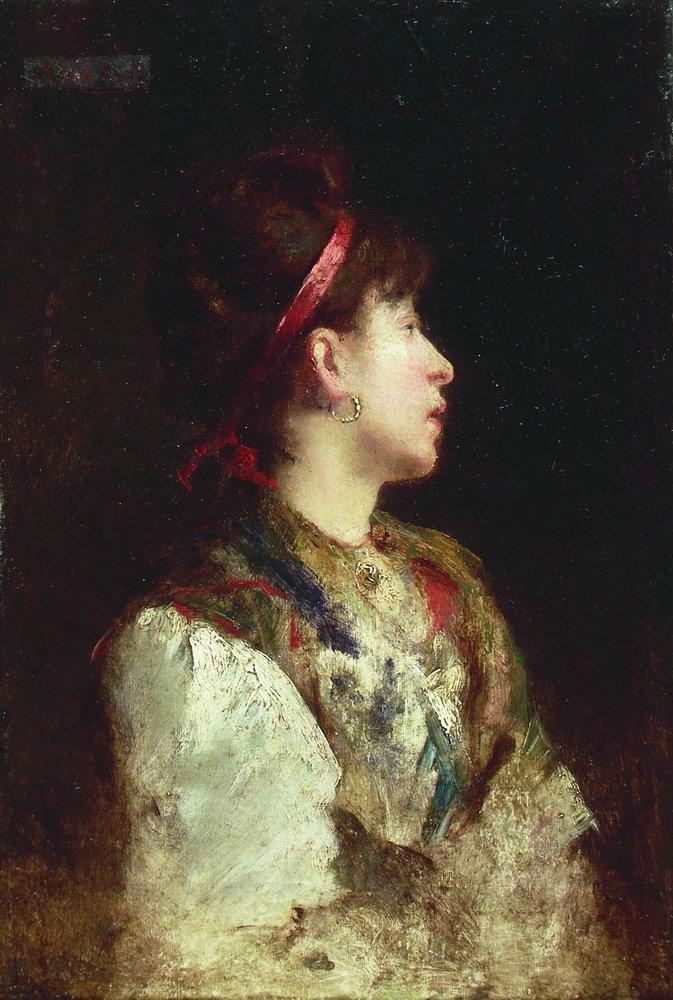Create a whimsical scenario involving an unexpected guest. One breezy afternoon, as Annaliese sat by her window, a peculiar thing happened. A tiny fairy, with wings sparkling like morning dew, fluttered into her room. The fairy, named Luminara, had heard of Annaliese’s renowned shawls and sought her help. In Luminara’s world, a great festival was approaching, and she needed an exceptional shawl to present to their queen. Annaliese, captivated by the fairy's charm, agreed. Together, they worked through the night, weaving threads of magic into the shawl. When the dawn broke, Luminara left with the most marvelous shawl ever seen, leaving behind a sprinkle of fairy dust and the sweetest scent of blooming lilies. For Annaliese, it was an encounter that made her believe in the magic hidden in everyday life. 